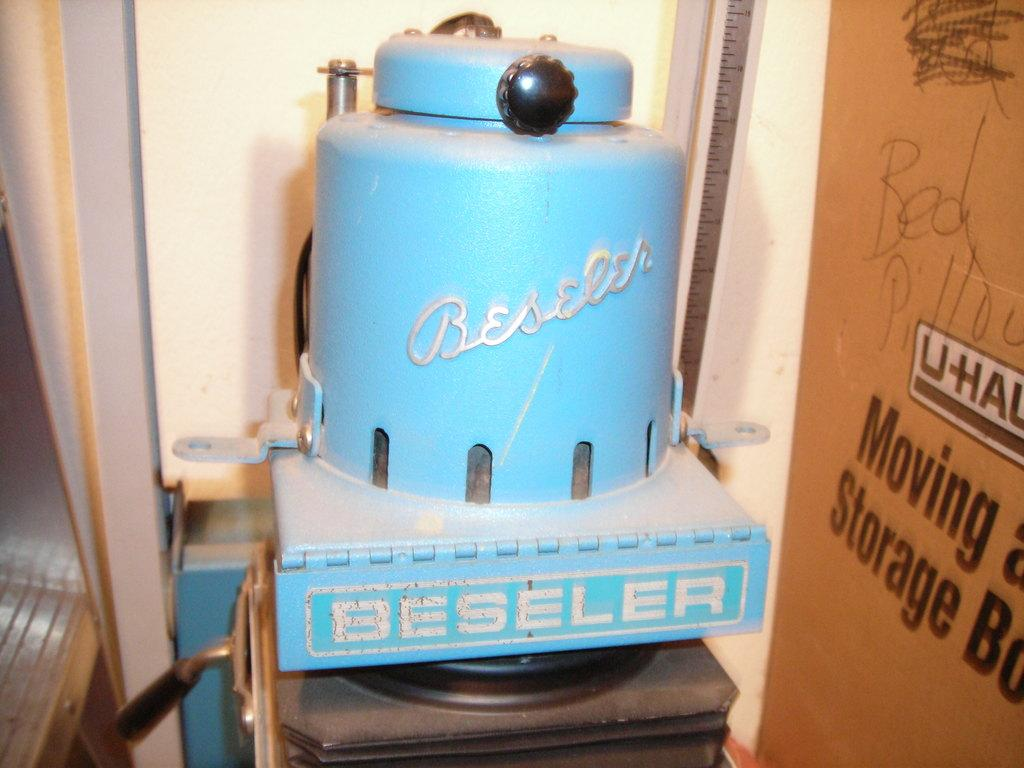What type of equipment can be seen in the image? There is photographic equipment in the image. Can you describe the equipment in more detail? Unfortunately, the provided facts do not offer more specific details about the photographic equipment. What might the purpose of this equipment be? The photographic equipment in the image is likely used for capturing or creating photographs or videos. What type of door can be seen in the image? There is no door present in the image; it features photographic equipment. How much salt is visible on the equipment in the image? There is no salt present on the equipment in the image. 